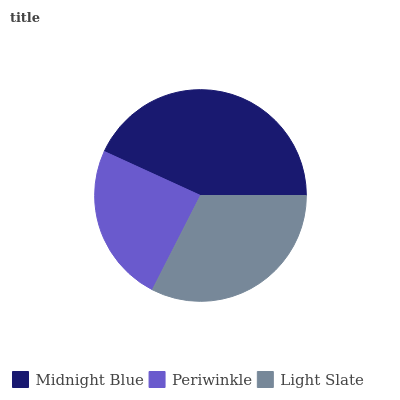Is Periwinkle the minimum?
Answer yes or no. Yes. Is Midnight Blue the maximum?
Answer yes or no. Yes. Is Light Slate the minimum?
Answer yes or no. No. Is Light Slate the maximum?
Answer yes or no. No. Is Light Slate greater than Periwinkle?
Answer yes or no. Yes. Is Periwinkle less than Light Slate?
Answer yes or no. Yes. Is Periwinkle greater than Light Slate?
Answer yes or no. No. Is Light Slate less than Periwinkle?
Answer yes or no. No. Is Light Slate the high median?
Answer yes or no. Yes. Is Light Slate the low median?
Answer yes or no. Yes. Is Periwinkle the high median?
Answer yes or no. No. Is Periwinkle the low median?
Answer yes or no. No. 